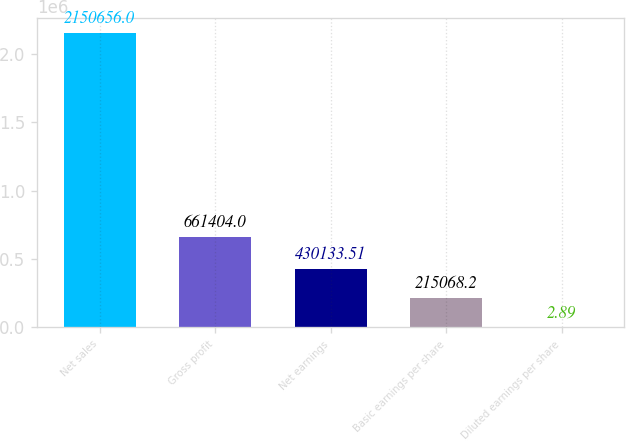<chart> <loc_0><loc_0><loc_500><loc_500><bar_chart><fcel>Net sales<fcel>Gross profit<fcel>Net earnings<fcel>Basic earnings per share<fcel>Diluted earnings per share<nl><fcel>2.15066e+06<fcel>661404<fcel>430134<fcel>215068<fcel>2.89<nl></chart> 